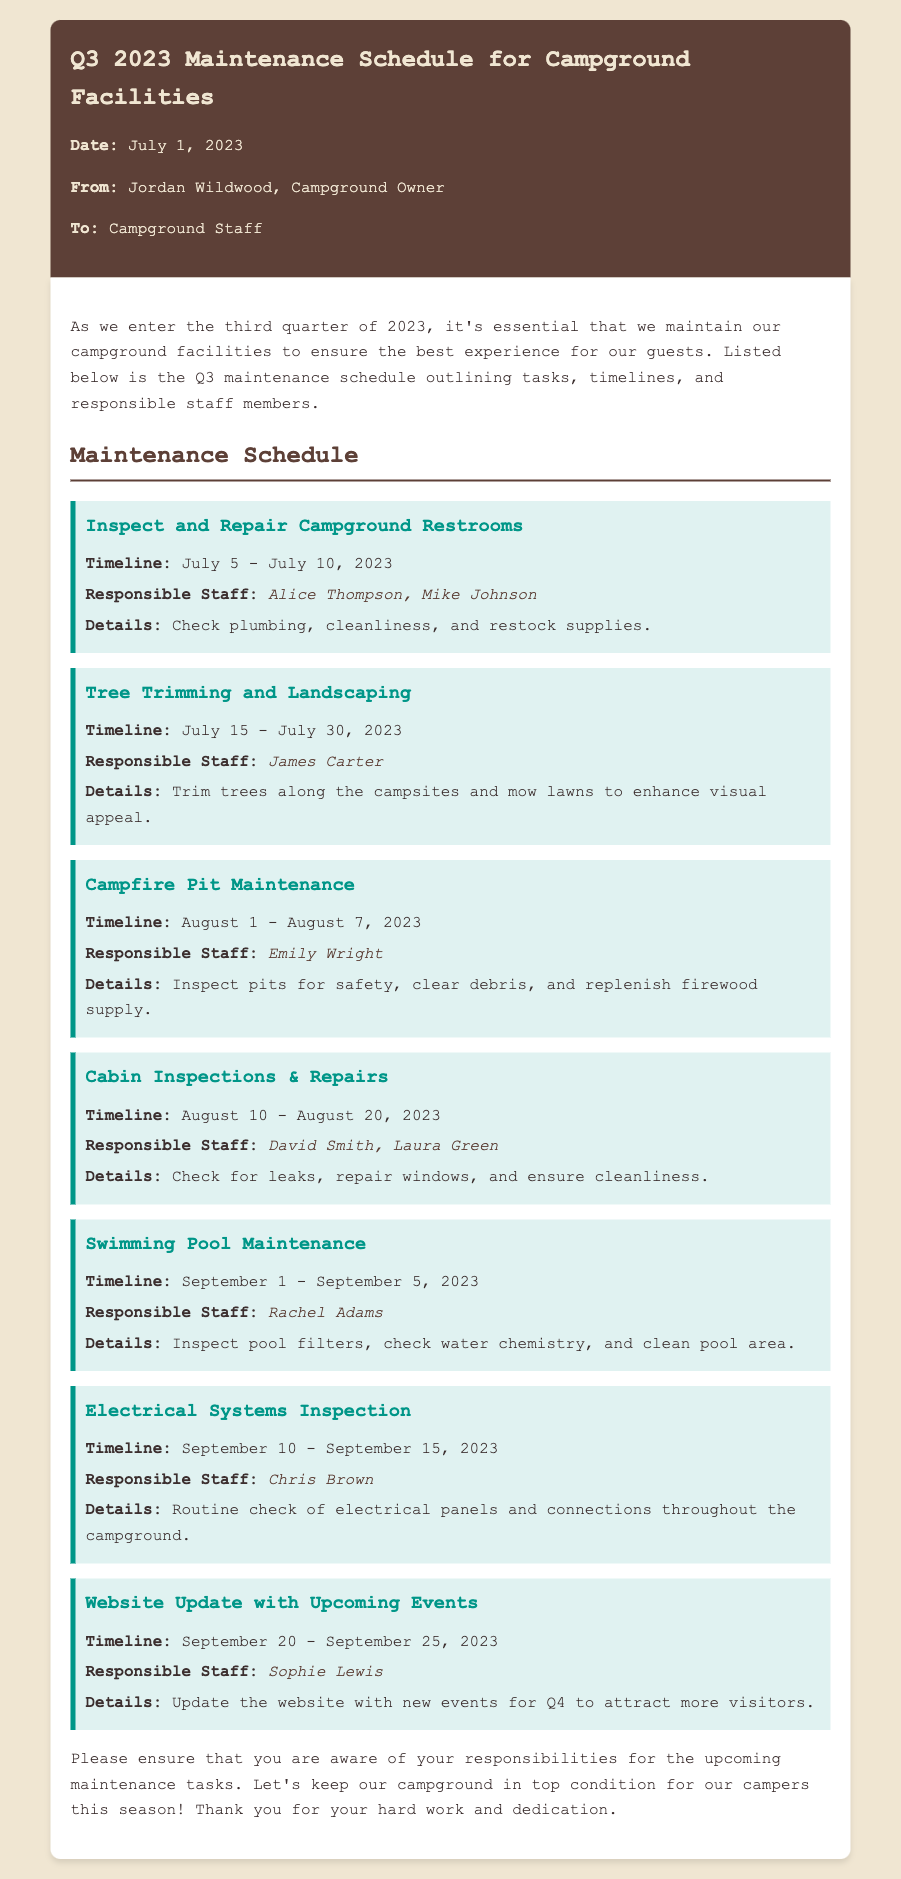What is the date of the memo? The memo's date is specified in the document as July 1, 2023.
Answer: July 1, 2023 Who is responsible for the inspection of the swimming pool? The document lists Rachel Adams as the responsible staff for swimming pool maintenance.
Answer: Rachel Adams What is the timeline for the cabin inspections and repairs? The timeline for this task is detailed as August 10 - August 20, 2023.
Answer: August 10 - August 20, 2023 How many staff members are involved in inspecting and repairing the campgrounds' restrooms? The document states that Alice Thompson and Mike Johnson are responsible, totaling two staff members.
Answer: Two What maintenance task occurs right before the electrical systems inspection? By analyzing the timeline, the swimming pool maintenance occurs right before electrical systems inspection.
Answer: Swimming Pool Maintenance Which task is scheduled for July 15 - July 30, 2023? The document indicates that tree trimming and landscaping are scheduled for that period.
Answer: Tree Trimming and Landscaping What is the main detail of the campfire pit maintenance? The primary detail mentioned involves inspecting pits for safety and clearing debris.
Answer: Inspect pits for safety, clear debris Who is tasked with updating the website with upcoming events? Sophie Lewis is identified as the responsible staff for this task in the document.
Answer: Sophie Lewis 